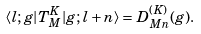Convert formula to latex. <formula><loc_0><loc_0><loc_500><loc_500>\langle l ; g | T ^ { K } _ { M } | g ; l + n \rangle = D ^ { ( K ) } _ { M n } ( g ) .</formula> 